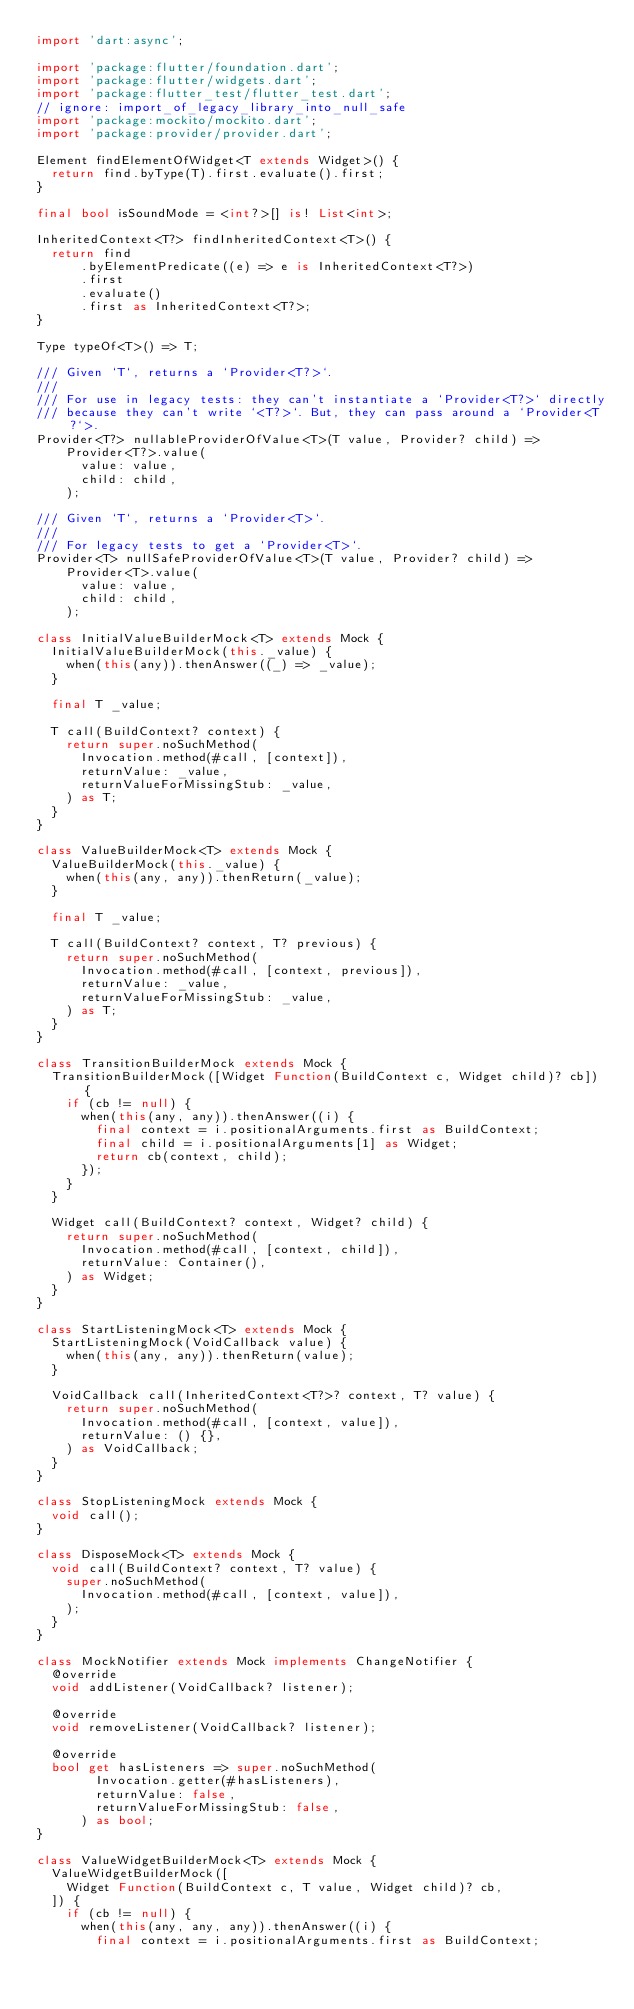Convert code to text. <code><loc_0><loc_0><loc_500><loc_500><_Dart_>import 'dart:async';

import 'package:flutter/foundation.dart';
import 'package:flutter/widgets.dart';
import 'package:flutter_test/flutter_test.dart';
// ignore: import_of_legacy_library_into_null_safe
import 'package:mockito/mockito.dart';
import 'package:provider/provider.dart';

Element findElementOfWidget<T extends Widget>() {
  return find.byType(T).first.evaluate().first;
}

final bool isSoundMode = <int?>[] is! List<int>;

InheritedContext<T?> findInheritedContext<T>() {
  return find
      .byElementPredicate((e) => e is InheritedContext<T?>)
      .first
      .evaluate()
      .first as InheritedContext<T?>;
}

Type typeOf<T>() => T;

/// Given `T`, returns a `Provider<T?>`.
///
/// For use in legacy tests: they can't instantiate a `Provider<T?>` directly
/// because they can't write `<T?>`. But, they can pass around a `Provider<T?`>.
Provider<T?> nullableProviderOfValue<T>(T value, Provider? child) =>
    Provider<T?>.value(
      value: value,
      child: child,
    );

/// Given `T`, returns a `Provider<T>`.
///
/// For legacy tests to get a `Provider<T>`.
Provider<T> nullSafeProviderOfValue<T>(T value, Provider? child) =>
    Provider<T>.value(
      value: value,
      child: child,
    );

class InitialValueBuilderMock<T> extends Mock {
  InitialValueBuilderMock(this._value) {
    when(this(any)).thenAnswer((_) => _value);
  }

  final T _value;

  T call(BuildContext? context) {
    return super.noSuchMethod(
      Invocation.method(#call, [context]),
      returnValue: _value,
      returnValueForMissingStub: _value,
    ) as T;
  }
}

class ValueBuilderMock<T> extends Mock {
  ValueBuilderMock(this._value) {
    when(this(any, any)).thenReturn(_value);
  }

  final T _value;

  T call(BuildContext? context, T? previous) {
    return super.noSuchMethod(
      Invocation.method(#call, [context, previous]),
      returnValue: _value,
      returnValueForMissingStub: _value,
    ) as T;
  }
}

class TransitionBuilderMock extends Mock {
  TransitionBuilderMock([Widget Function(BuildContext c, Widget child)? cb]) {
    if (cb != null) {
      when(this(any, any)).thenAnswer((i) {
        final context = i.positionalArguments.first as BuildContext;
        final child = i.positionalArguments[1] as Widget;
        return cb(context, child);
      });
    }
  }

  Widget call(BuildContext? context, Widget? child) {
    return super.noSuchMethod(
      Invocation.method(#call, [context, child]),
      returnValue: Container(),
    ) as Widget;
  }
}

class StartListeningMock<T> extends Mock {
  StartListeningMock(VoidCallback value) {
    when(this(any, any)).thenReturn(value);
  }

  VoidCallback call(InheritedContext<T?>? context, T? value) {
    return super.noSuchMethod(
      Invocation.method(#call, [context, value]),
      returnValue: () {},
    ) as VoidCallback;
  }
}

class StopListeningMock extends Mock {
  void call();
}

class DisposeMock<T> extends Mock {
  void call(BuildContext? context, T? value) {
    super.noSuchMethod(
      Invocation.method(#call, [context, value]),
    );
  }
}

class MockNotifier extends Mock implements ChangeNotifier {
  @override
  void addListener(VoidCallback? listener);

  @override
  void removeListener(VoidCallback? listener);

  @override
  bool get hasListeners => super.noSuchMethod(
        Invocation.getter(#hasListeners),
        returnValue: false,
        returnValueForMissingStub: false,
      ) as bool;
}

class ValueWidgetBuilderMock<T> extends Mock {
  ValueWidgetBuilderMock([
    Widget Function(BuildContext c, T value, Widget child)? cb,
  ]) {
    if (cb != null) {
      when(this(any, any, any)).thenAnswer((i) {
        final context = i.positionalArguments.first as BuildContext;</code> 